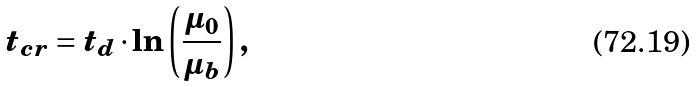Convert formula to latex. <formula><loc_0><loc_0><loc_500><loc_500>t _ { c r } = t _ { d } \cdot \ln \left ( \frac { \mu _ { 0 } } { \mu _ { b } } \right ) ,</formula> 